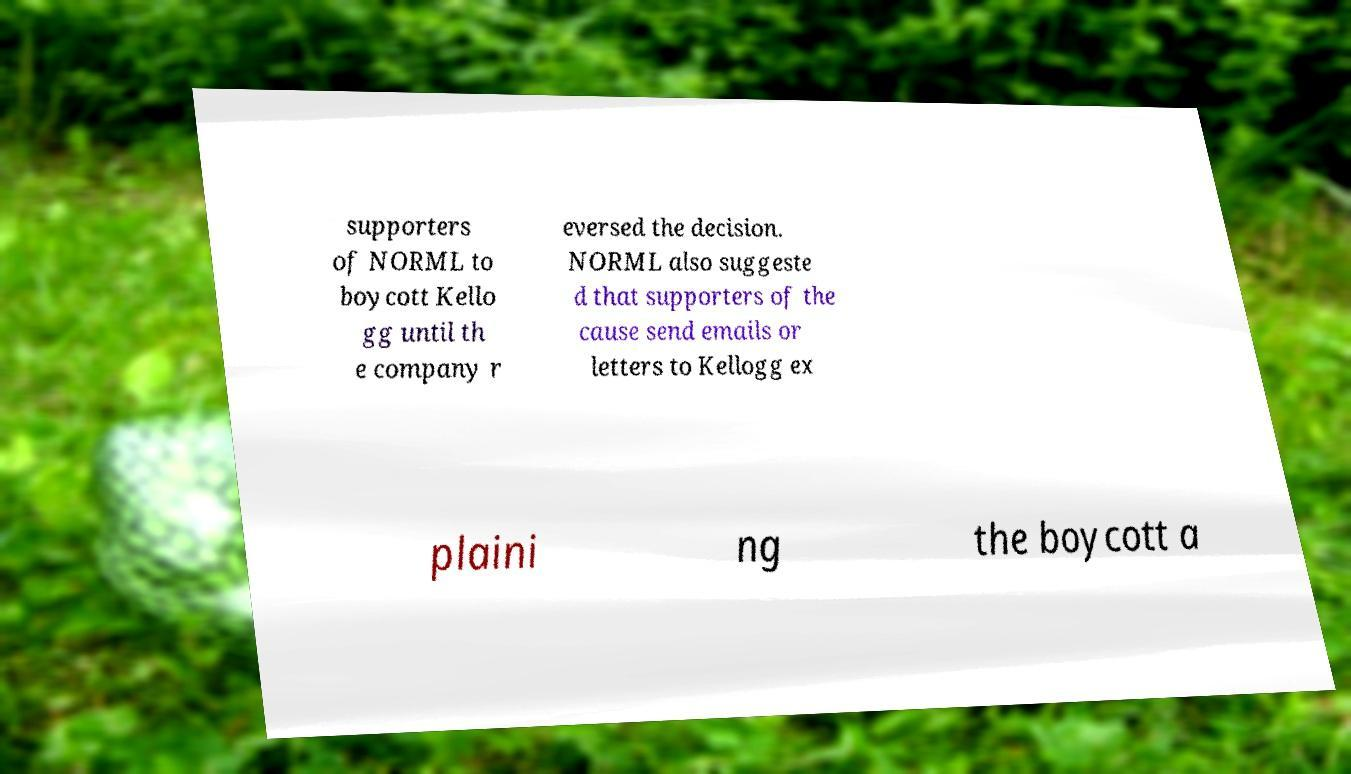Please read and relay the text visible in this image. What does it say? supporters of NORML to boycott Kello gg until th e company r eversed the decision. NORML also suggeste d that supporters of the cause send emails or letters to Kellogg ex plaini ng the boycott a 